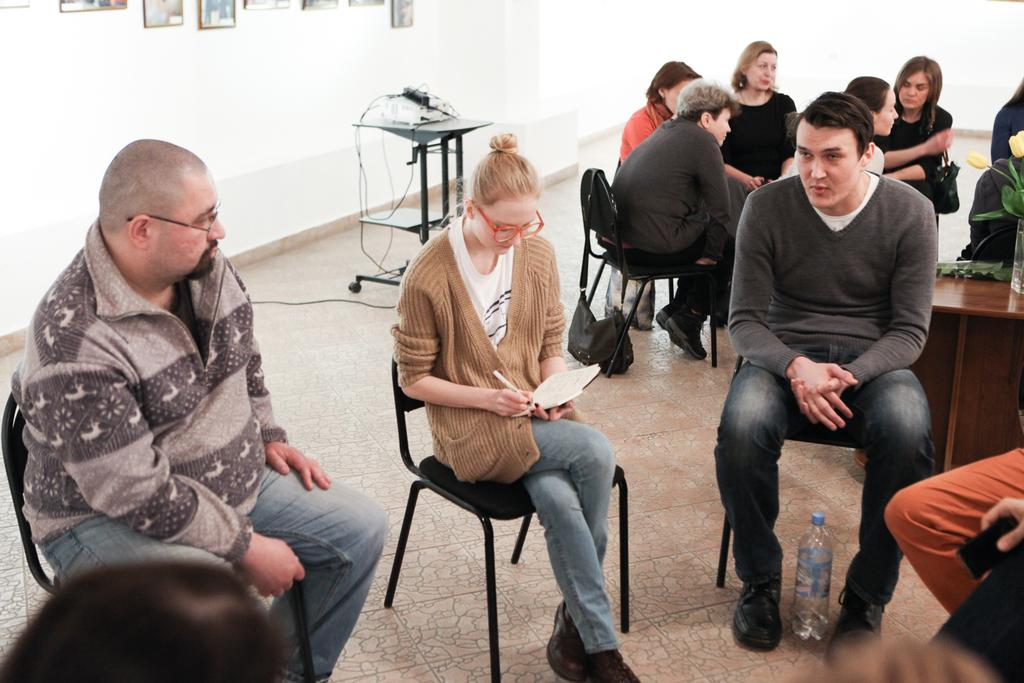What are the people in the image doing? There is a group of people sitting on chairs in the image. What object can be seen on a table in the image? There is a bottle on a table in the image. What can be seen on the wall in the image? There is a white color wall with photos in the image. What type of furniture is present on the floor in the image? There is a table on the floor in the image. How many balls are being juggled by the people in the image? There are no balls present in the image; the people are sitting on chairs. 